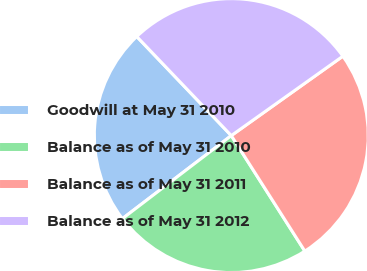Convert chart to OTSL. <chart><loc_0><loc_0><loc_500><loc_500><pie_chart><fcel>Goodwill at May 31 2010<fcel>Balance as of May 31 2010<fcel>Balance as of May 31 2011<fcel>Balance as of May 31 2012<nl><fcel>23.24%<fcel>23.65%<fcel>25.82%<fcel>27.28%<nl></chart> 